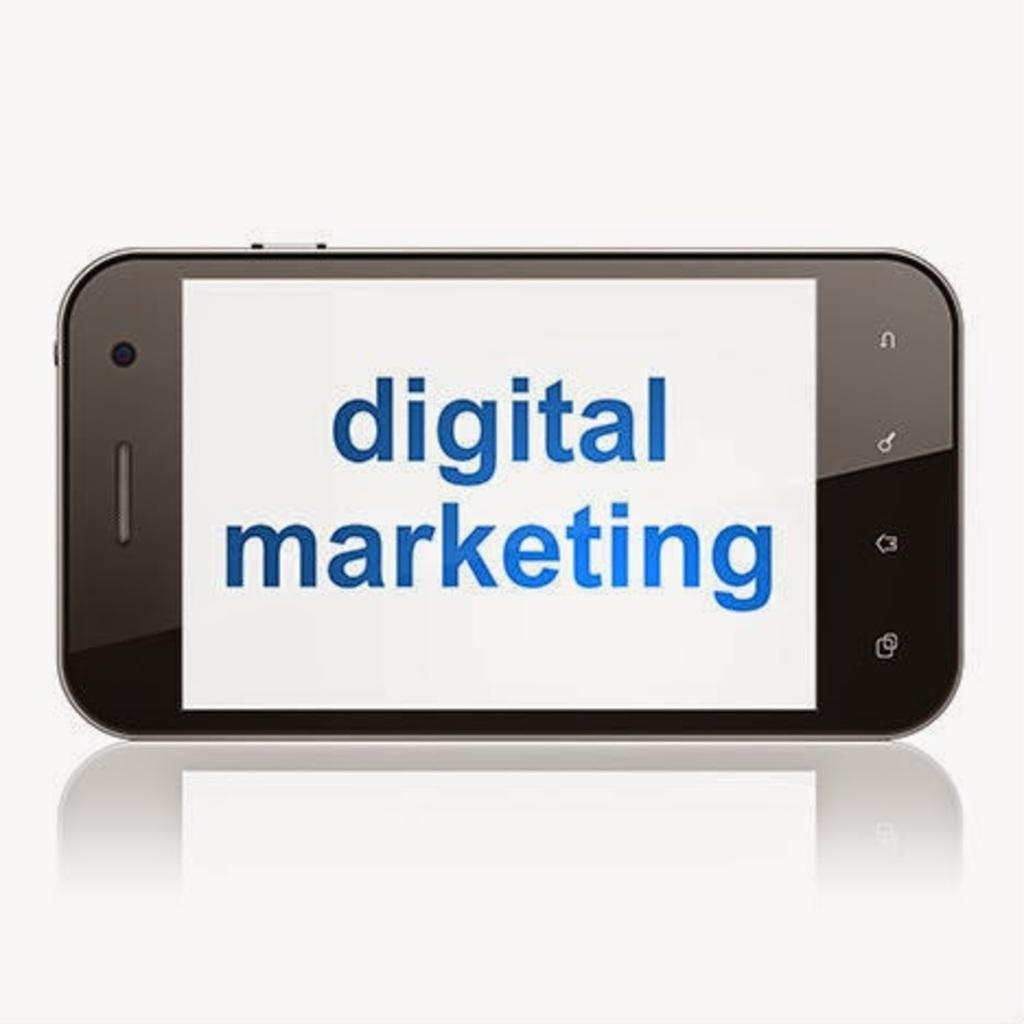<image>
Present a compact description of the photo's key features. phone screen with a white background and blue words that say digital marketing. 